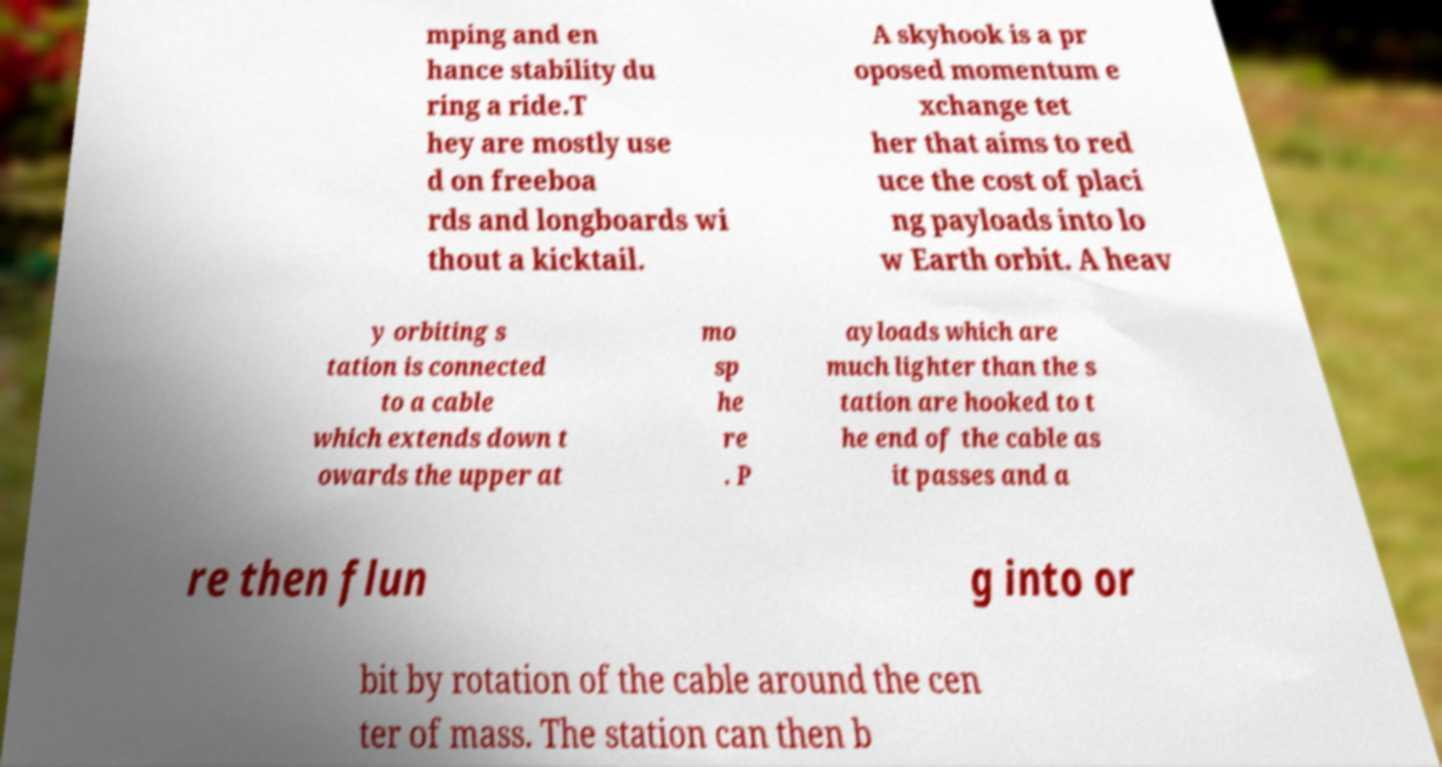Can you accurately transcribe the text from the provided image for me? mping and en hance stability du ring a ride.T hey are mostly use d on freeboa rds and longboards wi thout a kicktail. A skyhook is a pr oposed momentum e xchange tet her that aims to red uce the cost of placi ng payloads into lo w Earth orbit. A heav y orbiting s tation is connected to a cable which extends down t owards the upper at mo sp he re . P ayloads which are much lighter than the s tation are hooked to t he end of the cable as it passes and a re then flun g into or bit by rotation of the cable around the cen ter of mass. The station can then b 